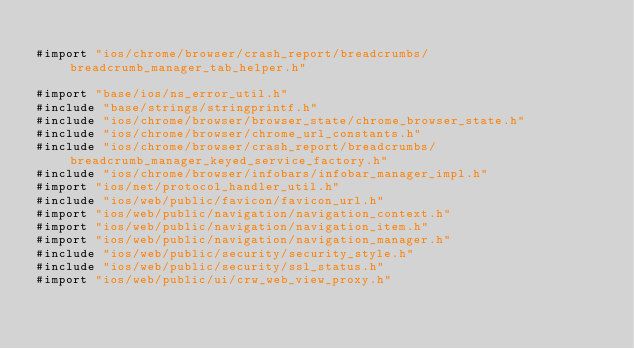Convert code to text. <code><loc_0><loc_0><loc_500><loc_500><_ObjectiveC_>
#import "ios/chrome/browser/crash_report/breadcrumbs/breadcrumb_manager_tab_helper.h"

#import "base/ios/ns_error_util.h"
#include "base/strings/stringprintf.h"
#include "ios/chrome/browser/browser_state/chrome_browser_state.h"
#include "ios/chrome/browser/chrome_url_constants.h"
#include "ios/chrome/browser/crash_report/breadcrumbs/breadcrumb_manager_keyed_service_factory.h"
#include "ios/chrome/browser/infobars/infobar_manager_impl.h"
#import "ios/net/protocol_handler_util.h"
#include "ios/web/public/favicon/favicon_url.h"
#import "ios/web/public/navigation/navigation_context.h"
#import "ios/web/public/navigation/navigation_item.h"
#import "ios/web/public/navigation/navigation_manager.h"
#include "ios/web/public/security/security_style.h"
#include "ios/web/public/security/ssl_status.h"
#import "ios/web/public/ui/crw_web_view_proxy.h"</code> 